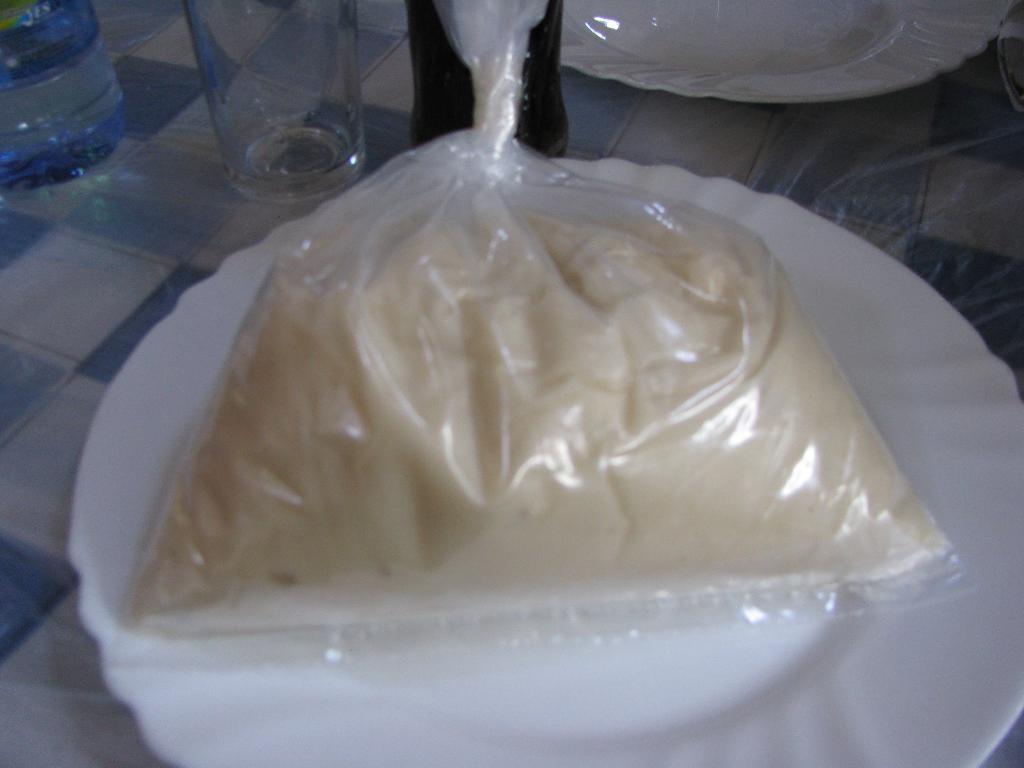Describe this image in one or two sentences. In this image i can see a table on which there is a glass, a water bottle, a cool drink bottle and 2 plates on which there is a packet of some food item. 